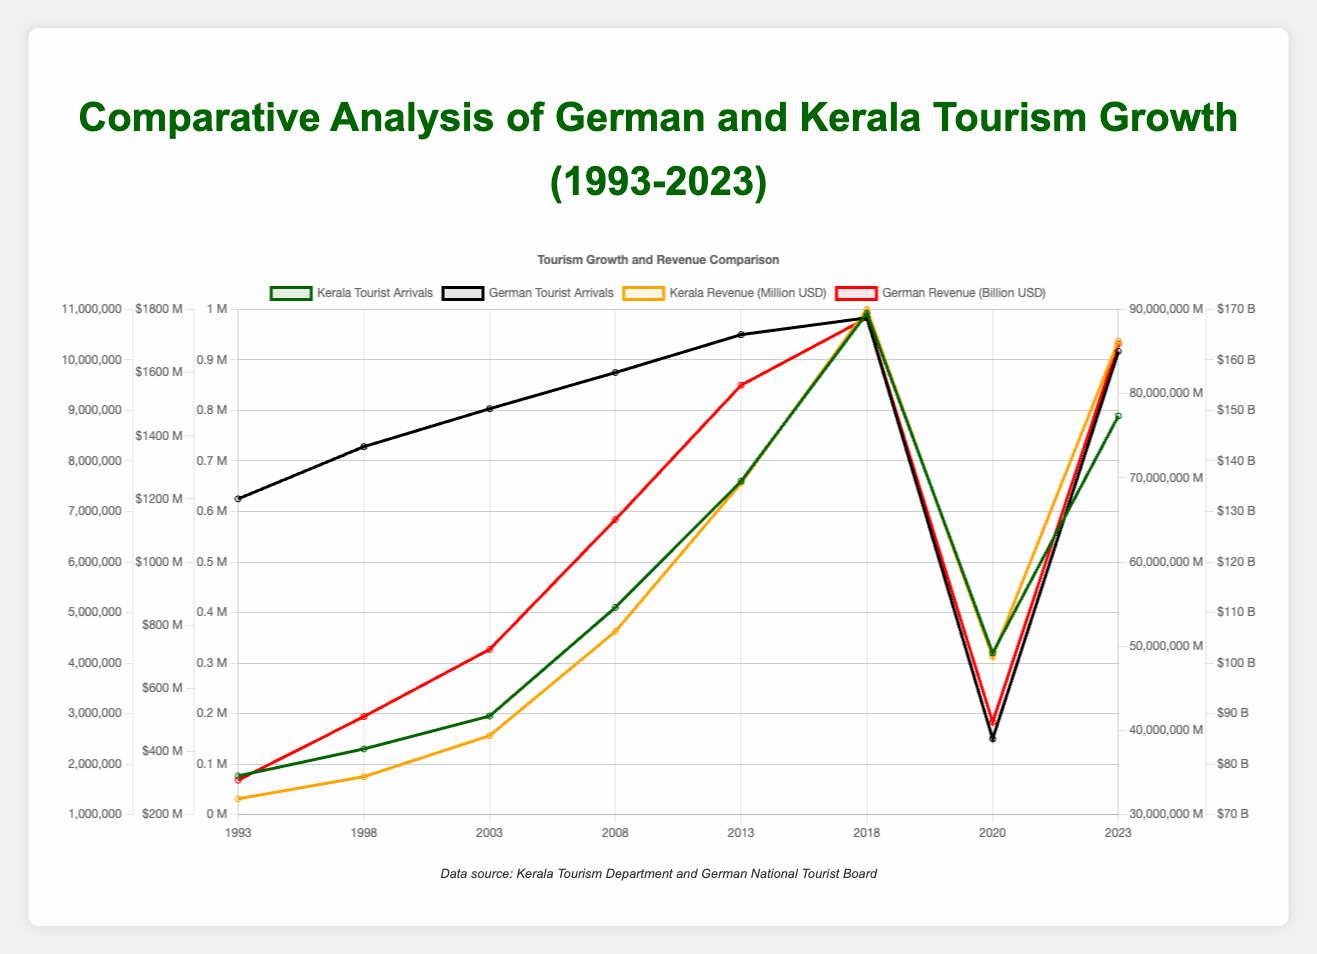What trend is observed in Kerala tourist arrivals from 1993 to 2023? To identify the trend, look at the line representing Kerala tourist arrivals. Starting from 1993, the number of arrivals increases steadily, peaking at 10.923 million in 2018. There is a drop in 2020 to 4.2 million due to the likely impact of the COVID-19 pandemic, then a recovery to 8.89 million in 2023.
Answer: Steady increase, dip in 2020, recovery by 2023 How did the COVID-19 pandemic affect the tourism sectors of Kerala and Germany? Compare the number of tourist arrivals and tourism revenue in 2020 to the previous and following years for both Kerala and Germany. Both saw a significant drop in tourist arrivals and revenue in 2020. Kerala's tourist arrivals fell from 10.923 million in 2018 to 4.2 million, and revenue dropped from $1800 million to $700 million. In Germany, tourist arrivals dropped from 89 million to 39 million, and revenue fell from $168.3 billion to $88.3 billion.
Answer: Sharp decline in both tourist arrivals and revenue for both Which country had a greater drop in tourist arrivals in 2020 compared to 2018, Kerala or Germany? Calculate the difference in tourist arrivals from 2018 to 2020 for both regions. In Kerala, the drop is 10.923 million - 4.2 million = 6.723 million. In Germany, the drop is 89 million - 39 million = 50 million. Germany had a greater drop.
Answer: Germany What is the percentage increase in Kerala's tourism revenue from 1993 to 2018? Calculate the percentage increase using the formula ((Final - Initial) / Initial) * 100. The initial revenue in 1993 was $250 million, and the final in 2018 was $1800 million. So, ((1800 - 250) / 250) * 100 = 620%.
Answer: 620% By how much did the revenue from tourism in Germany increase from 1993 to 2023? Subtract the 1993 value from the 2023 value for German tourism revenue. In 1993, the revenue was $76.8 billion, and in 2023 it was $163.2 billion. Thus, $163.2 billion - $76.8 billion = $86.4 billion.
Answer: $86.4 billion Compare the line colors that represent the tourist arrivals for Kerala and Germany. Identify the line colors in the legend and compare. The line for Kerala tourist arrivals is green, whereas the line for German tourist arrivals is black.
Answer: Kerala: green, Germany: black Which year saw the highest tourist arrivals in Germany, and what was the number? Look at the peak of the line representing German tourist arrivals. The peak is in 2018, with 89 million tourist arrivals.
Answer: 2018, 89 million What visual clues indicate the revenue trends for both Kerala and Germany over the years? Examine the color and trend of the lines representing revenue. The Kerala revenue line is orange, showing an increasing trend from 1993 to 2018, a drop in 2020, and recovery in 2023. The German revenue line is red, showing a steady increase till 2018, a dip in 2020, and partial recovery by 2023.
Answer: Kerala: orange, Germany: red, steadily increasing, dip in 2020, partial recovery In 2013, what was the difference in tourism revenue between Kerala and Germany? Find the revenue values for both regions in 2013 from the chart. Kerala's revenue was $1250 million, and Germany's was $155 billion. Convert $155 billion to million by multiplying by 1000, so $155,000 million. The difference is $155,000 million - $1250 million = $153,750 million.
Answer: $153,750 million How did the tourist arrivals in Kerala in 2023 compare to those in 2018? Compare the two points 2018 and 2023 on the Kerala tourist arrivals line. In 2018, the arrivals were 10.923 million, and in 2023, they were 8.89 million. Thus, the arrivals in 2023 were lower by 2.033 million compared to 2018.
Answer: 2.033 million less 